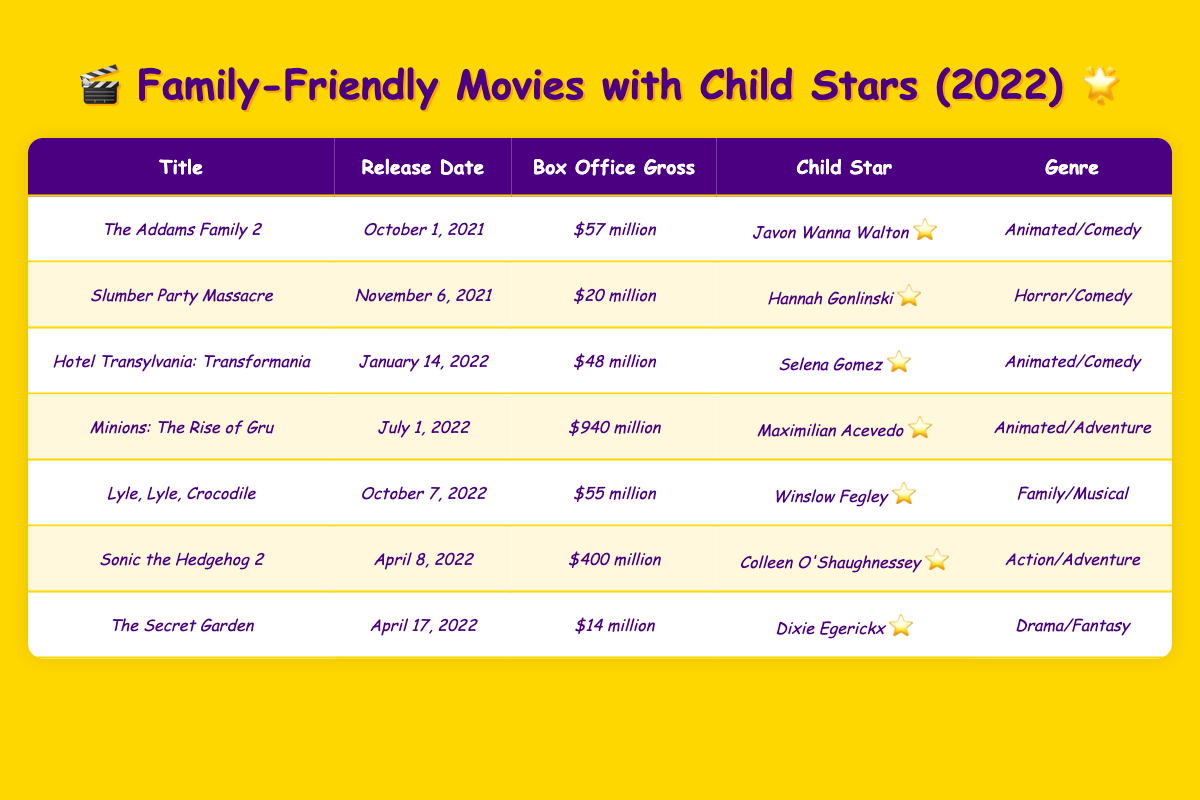What is the box office gross of *Minions: The Rise of Gru*? From the table, the entry for *Minions: The Rise of Gru* shows that the box office gross is *$940 million*.
Answer: $940 million Who stars in *Lyle, Lyle, Crocodile*? According to the table, the child star in *Lyle, Lyle, Crocodile* is *Winslow Fegley*.
Answer: Winslow Fegley Which movie had the highest box office gross in 2022? By reviewing the table, *Minions: The Rise of Gru* has the highest box office gross at *$940 million*.
Answer: *Minions: The Rise of Gru* What are the genres of the movies listed in the table? The genres of the movies in the table include Animated/Comedy, Horror/Comedy, Animated/Adventure, Family/Musical, Action/Adventure, Drama/Fantasy.
Answer: Multiple genres Is *Sonic the Hedgehog 2* an animated movie? The table shows that *Sonic the Hedgehog 2* is classified as *Action/Adventure*, which means it is not primarily an animated movie.
Answer: No What is the average box office gross of the movies listed in 2022? To find the average, sum the box office gross of the relevant movies: ($48 million + $940 million + $55 million + $400 million + $14 million) = $1,457 million. There are 5 movies listed for 2022, so the average is $1,457 million / 5 = $291.4 million.
Answer: $291.4 million Which child star has the lowest box office gross associated with their movie? Looking at the box office gross figures, *Dixie Egerickx* in *The Secret Garden* has the lowest gross at *$14 million*.
Answer: Dixie Egerickx How many movies in the table were released in 2022? The movies released in 2022 based on the table entries are *Hotel Transylvania: Transformania*, *Minions: The Rise of Gru*, *Lyle, Lyle, Crocodile*, *Sonic the Hedgehog 2*, and *The Secret Garden*, which makes a total of 5 movies.
Answer: 5 What is the total box office gross of family-friendly movies featuring child stars in the table? Summing the box office grosses: $57 million + $20 million + $48 million + $940 million + $55 million + $400 million + $14 million = $1,634 million.
Answer: $1,634 million Which movie was released the earliest in the table? The release dates indicate that *The Addams Family 2* was released on *October 1, 2021*, making it the earliest release.
Answer: *The Addams Family 2* Which child star has appeared in the most successful movie according to its box office gross? The highest box office gross is *$940 million* for *Minions: The Rise of Gru*, which features *Maximilian Acevedo*. Therefore, he is the child star in the most successful movie.
Answer: Maximilian Acevedo 